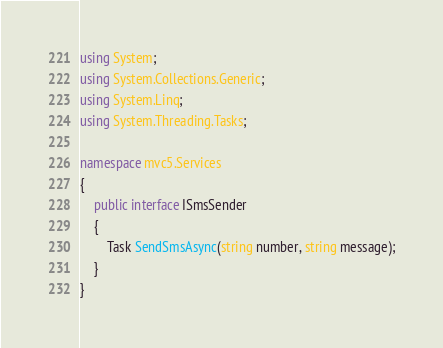<code> <loc_0><loc_0><loc_500><loc_500><_C#_>using System;
using System.Collections.Generic;
using System.Linq;
using System.Threading.Tasks;

namespace mvc5.Services
{
    public interface ISmsSender
    {
        Task SendSmsAsync(string number, string message);
    }
}
</code> 